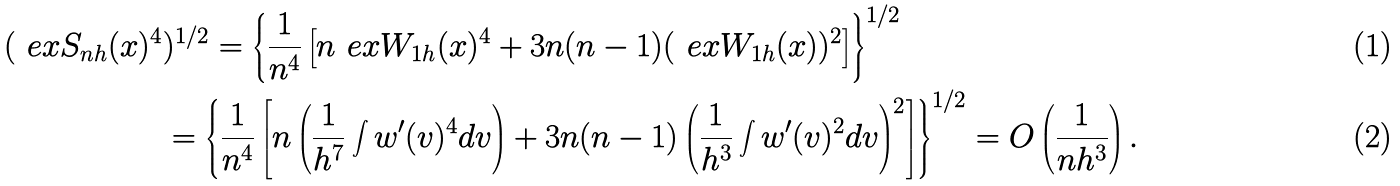Convert formula to latex. <formula><loc_0><loc_0><loc_500><loc_500>( \ e x S _ { n h } ( x ) ^ { 4 } & ) ^ { 1 / 2 } = \left \{ \frac { 1 } { n ^ { 4 } } \left [ n \ e x W _ { 1 h } ( x ) ^ { 4 } + 3 n ( n - 1 ) ( \ e x W _ { 1 h } ( x ) ) ^ { 2 } \right ] \right \} ^ { 1 / 2 } \\ & = \left \{ \frac { 1 } { n ^ { 4 } } \left [ n \left ( \frac { 1 } { h ^ { 7 } } \int w ^ { \prime } ( v ) ^ { 4 } d v \right ) + 3 n ( n - 1 ) \left ( \frac { 1 } { h ^ { 3 } } \int w ^ { \prime } ( v ) ^ { 2 } d v \right ) ^ { 2 } \right ] \right \} ^ { 1 / 2 } = O \left ( \frac { 1 } { n h ^ { 3 } } \right ) .</formula> 